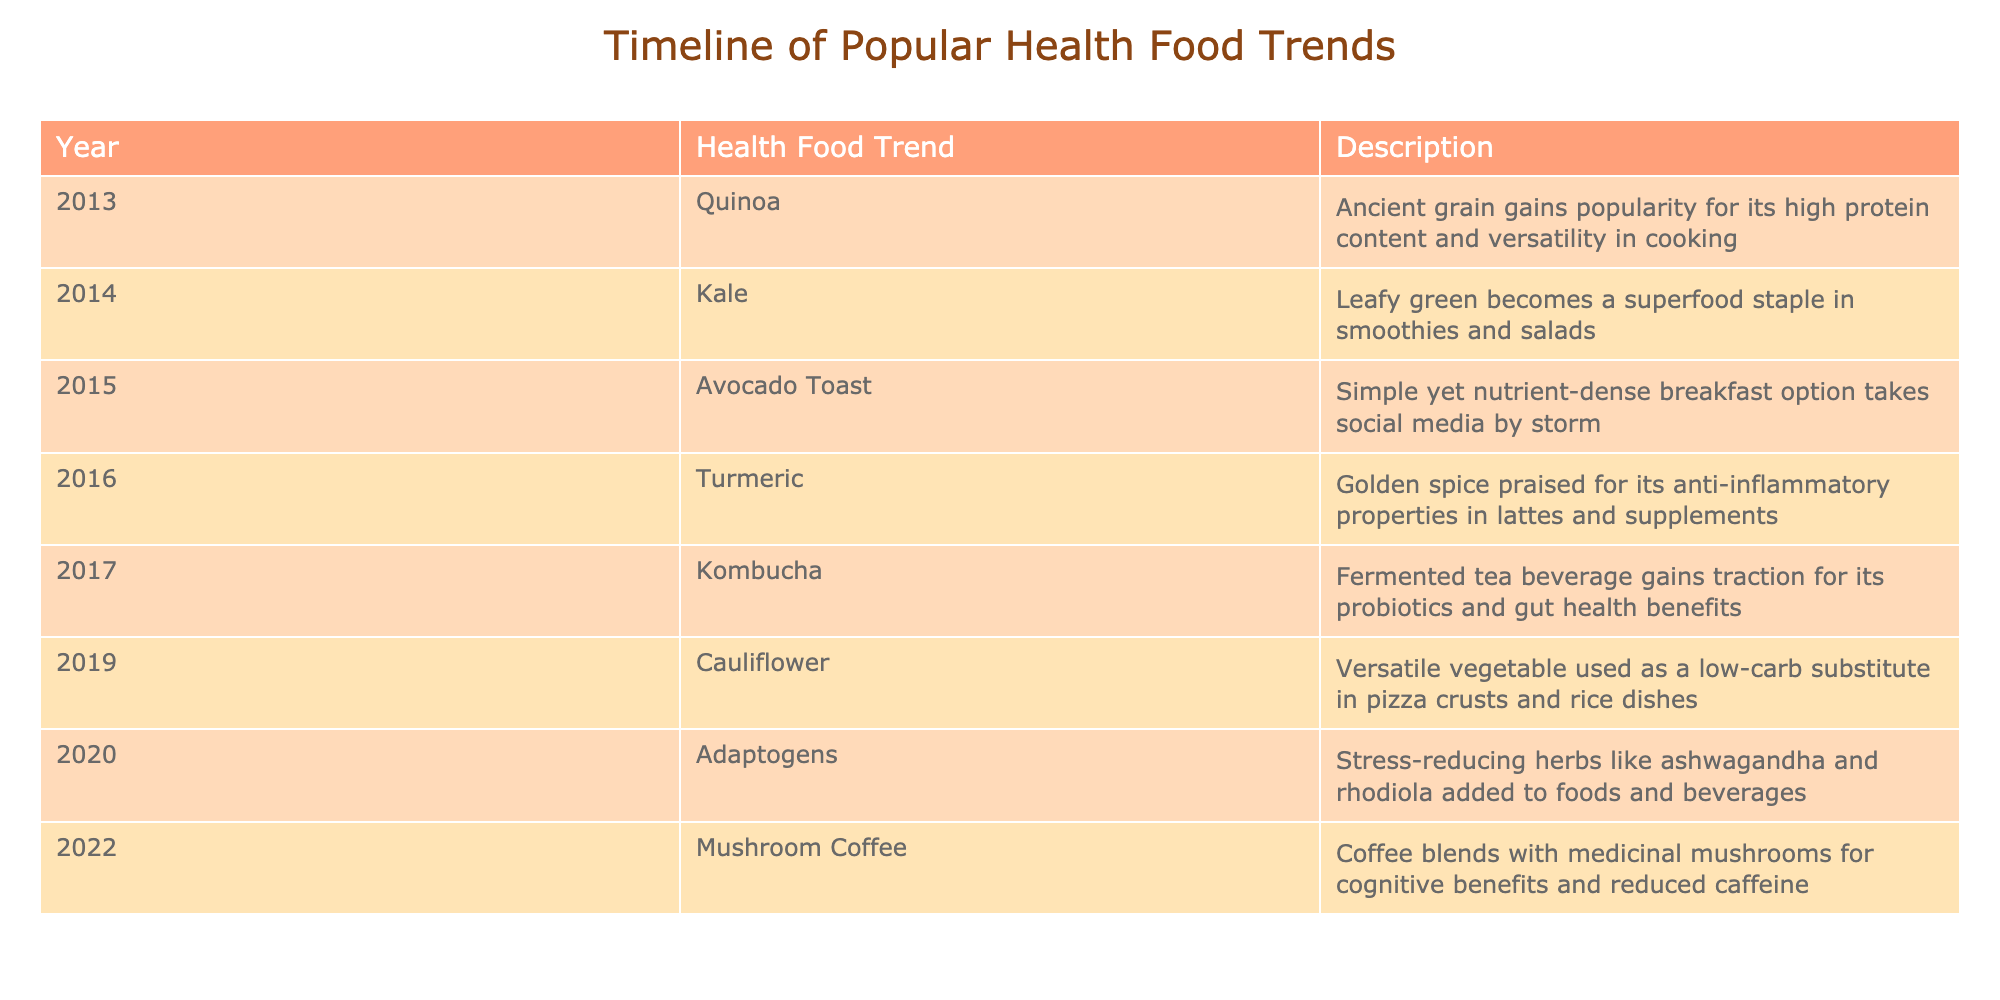What year did quinoa become popular? Quinoa is listed as a health food trend for the year 2013 in the table.
Answer: 2013 What is the main benefit attributed to turmeric? The table mentions turmeric is praised for its anti-inflammatory properties, which is its main benefit.
Answer: Anti-inflammatory properties Which health food trend followed kombucha? Kombucha is recorded in the year 2017, and the next trend listed is cauliflower in 2019, indicating that cauliflower followed kombucha.
Answer: Cauliflower How many trends are there between kale and mushroom coffee? Kale was popular in 2014, and mushroom coffee appeared in 2022. Counting the trends between them: avocado toast (2015), turmeric (2016), kombucha (2017), cauliflower (2019), and adaptogens (2020) gives a total of five trends.
Answer: 5 Is mushroom coffee associated with reduced caffeine? Yes, the description states that mushroom coffee blends are noted for reduced caffeine along with cognitive benefits.
Answer: Yes What health food trend has the longest gap in years between it and the previous trend? Looking at the table, the longest gap is between kombucha (2017) and cauliflower (2019), with a gap of 2 years, as all other trends are 1 year apart.
Answer: 2 years Which health food trend was popular in 2020? According to the table, the health food trend indicated for the year 2020 is adaptogens.
Answer: Adaptogens What was the trend characterized by social media popularity and described as a nutrient-dense breakfast? The trend described as a nutrient-dense breakfast that took social media by storm is avocado toast from 2015.
Answer: Avocado toast Which trends were identified as superfoods? Both kale (2014) and turmeric (2016) are referred to as superfoods in their descriptions within the table.
Answer: Kale and Turmeric 